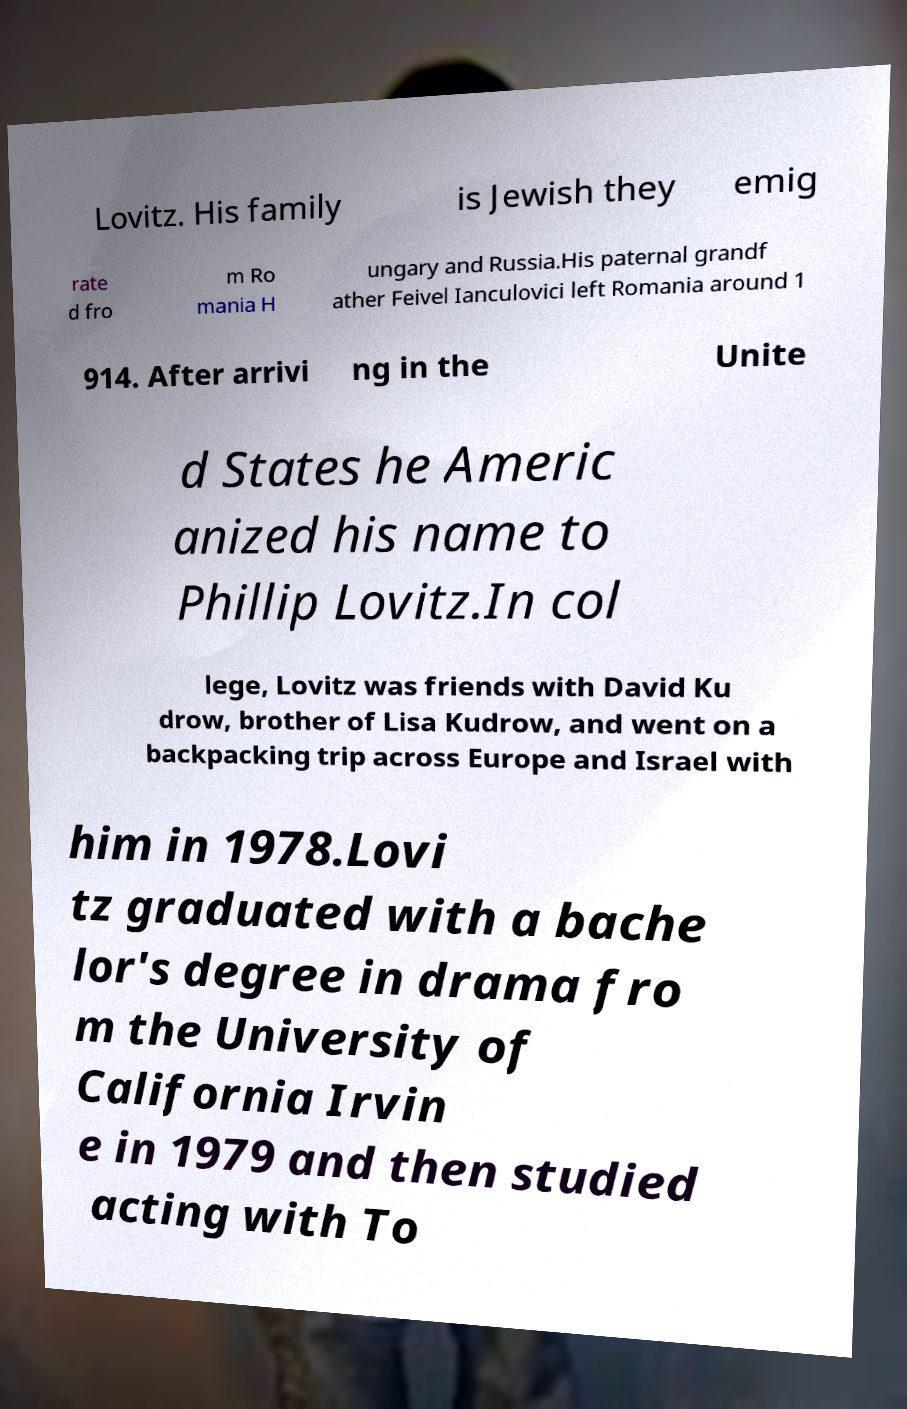What messages or text are displayed in this image? I need them in a readable, typed format. Lovitz. His family is Jewish they emig rate d fro m Ro mania H ungary and Russia.His paternal grandf ather Feivel Ianculovici left Romania around 1 914. After arrivi ng in the Unite d States he Americ anized his name to Phillip Lovitz.In col lege, Lovitz was friends with David Ku drow, brother of Lisa Kudrow, and went on a backpacking trip across Europe and Israel with him in 1978.Lovi tz graduated with a bache lor's degree in drama fro m the University of California Irvin e in 1979 and then studied acting with To 